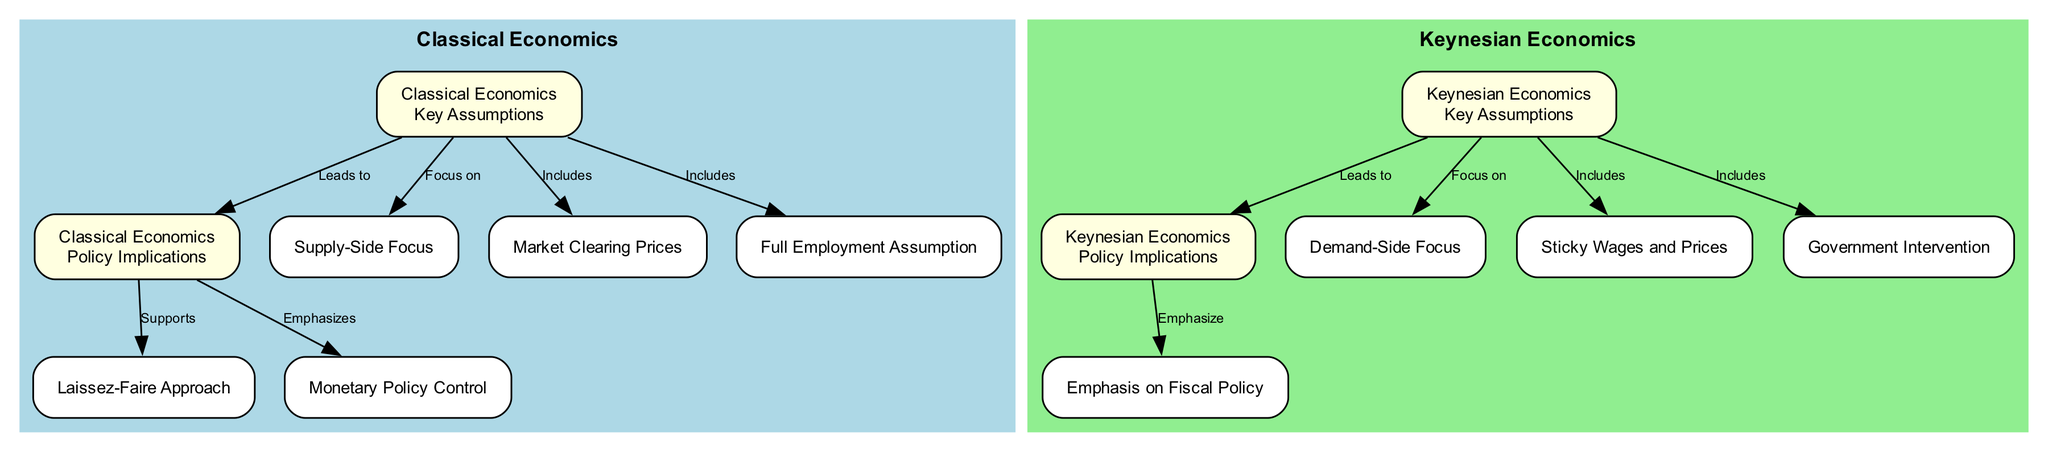What are the main focuses of Classical Economics? The diagram outlines that the Classical Economics nodes highlight a supply-side focus. The edge from "Assumptions_Classic" to "Supply_Classic" indicates this as a primary focus.
Answer: Supply-Side Focus What type of policy does Keynesian Economics emphasize? The diagram shows an edge leading from "Policies_Keynesian" to "Fiscal_Policy_Keynesian", which indicates that Keynesian Economics emphasizes fiscal policy.
Answer: Emphasis on Fiscal Policy Which aspect is included in the assumptions of Keynesian Economics? The diagram indicates several components under "Assumptions_Keynesian", including "Sticky Wages and Prices" which is explicitly mentioned as included in the assumptions.
Answer: Sticky Wages and Prices How many nodes display the policy implications of Classical Economics? The diagram presents two nodes for policy implications under Classical Economics, "Laissez-Faire Approach" and "Monetary Policy Control," indicating that there are two nodes focused specifically on this.
Answer: Two What relationship is shown between assumptions and policies in Classical Economics? The diagram illustrates a direct connection where assumptions lead to policy implications, as indicated by the edge labeled "Leads to" from "Assumptions_Classic" to "Policies_Classic."
Answer: Leads to What is the focus of Keynesian Economics according to the diagram? The diagram specifies the focus of Keynesian Economics as demand-side, illustrated by the connection from "Assumptions_Keynesian" to "Demand_Side."
Answer: Demand-Side Focus What kind of approach does Classical Economics support according to its policies? The edge connecting "Policies_Classic" to "Laissez_Faire_Classic" indicates that Classical Economics supports a laissez-faire approach.
Answer: Laissez-Faire Approach What does the diagram suggest about market prices in Classical Economics? The diagram shows an edge labeled "Includes" from "Assumptions_Classic" to "Market_Clear_Classic," revealing that Classical Economics assumes market clearing prices.
Answer: Market Clearing Prices What type of economic focus is indicated by Keynesian assumptions? The node connected to "Assumptions_Keynesian" indicates that Keynesian assumptions focus on demand, as clearly stated in the node "Demand-Side Focus."
Answer: Demand-Side Focus 